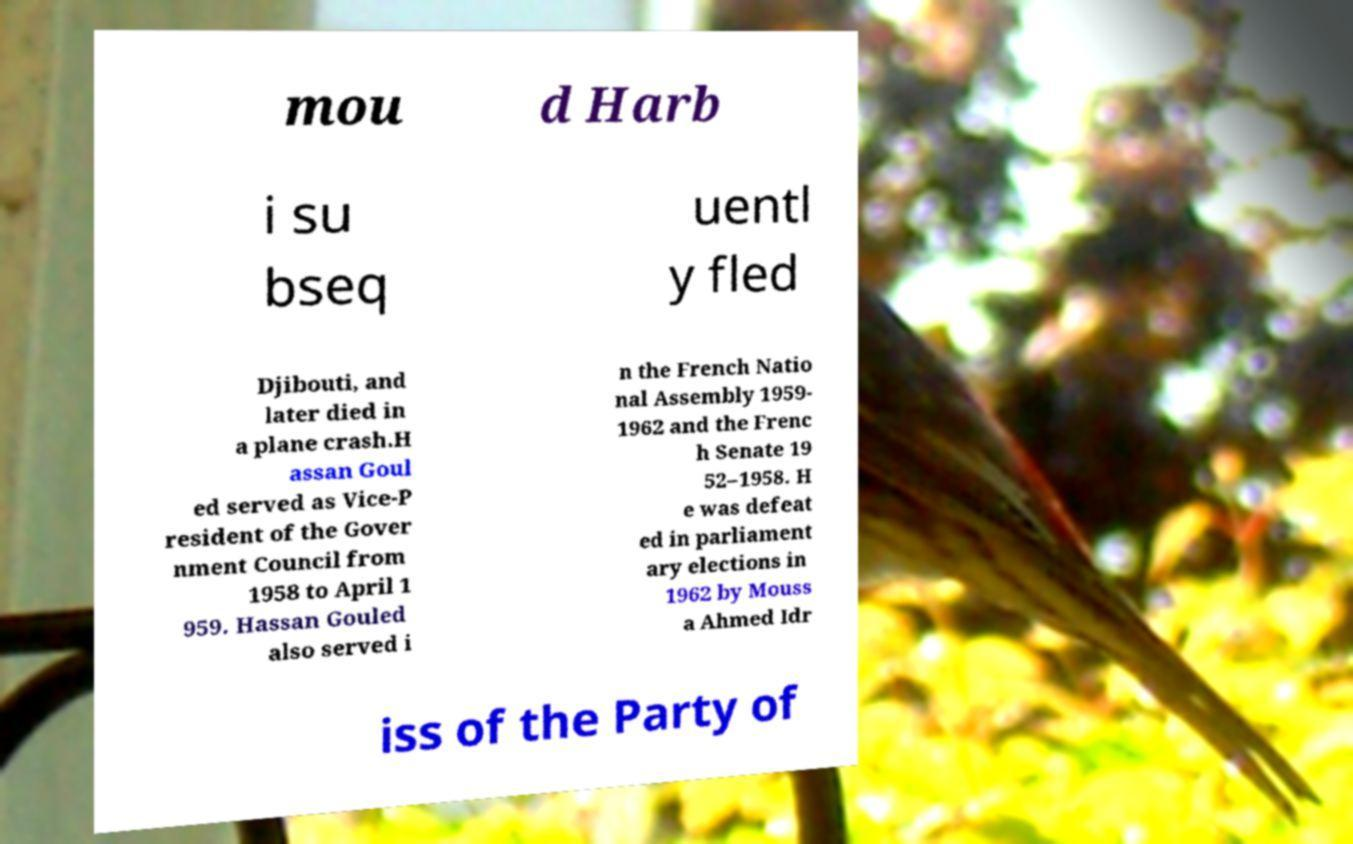I need the written content from this picture converted into text. Can you do that? mou d Harb i su bseq uentl y fled Djibouti, and later died in a plane crash.H assan Goul ed served as Vice-P resident of the Gover nment Council from 1958 to April 1 959. Hassan Gouled also served i n the French Natio nal Assembly 1959- 1962 and the Frenc h Senate 19 52–1958. H e was defeat ed in parliament ary elections in 1962 by Mouss a Ahmed Idr iss of the Party of 